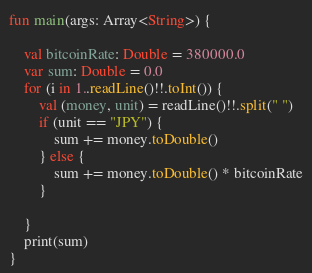Convert code to text. <code><loc_0><loc_0><loc_500><loc_500><_Kotlin_>fun main(args: Array<String>) {

    val bitcoinRate: Double = 380000.0
    var sum: Double = 0.0
    for (i in 1..readLine()!!.toInt()) {
        val (money, unit) = readLine()!!.split(" ")
        if (unit == "JPY") {
            sum += money.toDouble()
        } else {
            sum += money.toDouble() * bitcoinRate
        }

    }
    print(sum)
}</code> 